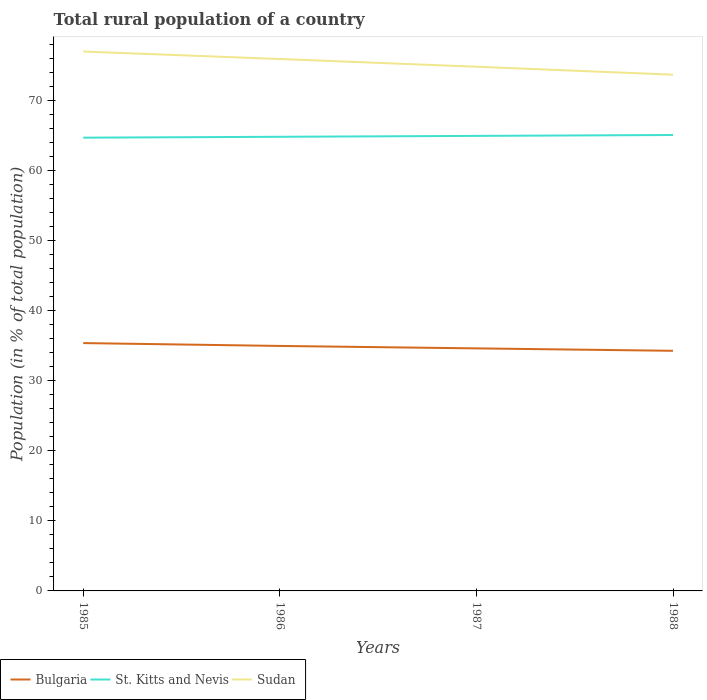How many different coloured lines are there?
Your response must be concise. 3. Is the number of lines equal to the number of legend labels?
Give a very brief answer. Yes. Across all years, what is the maximum rural population in Sudan?
Keep it short and to the point. 73.76. What is the total rural population in Bulgaria in the graph?
Provide a short and direct response. 1.1. What is the difference between the highest and the second highest rural population in Sudan?
Provide a short and direct response. 3.31. What is the difference between the highest and the lowest rural population in St. Kitts and Nevis?
Offer a terse response. 2. How many lines are there?
Your response must be concise. 3. How many years are there in the graph?
Offer a very short reply. 4. What is the difference between two consecutive major ticks on the Y-axis?
Keep it short and to the point. 10. Are the values on the major ticks of Y-axis written in scientific E-notation?
Offer a terse response. No. Where does the legend appear in the graph?
Give a very brief answer. Bottom left. How many legend labels are there?
Provide a short and direct response. 3. How are the legend labels stacked?
Make the answer very short. Horizontal. What is the title of the graph?
Your response must be concise. Total rural population of a country. What is the label or title of the X-axis?
Keep it short and to the point. Years. What is the label or title of the Y-axis?
Keep it short and to the point. Population (in % of total population). What is the Population (in % of total population) in Bulgaria in 1985?
Give a very brief answer. 35.41. What is the Population (in % of total population) in St. Kitts and Nevis in 1985?
Make the answer very short. 64.76. What is the Population (in % of total population) in Sudan in 1985?
Offer a very short reply. 77.06. What is the Population (in % of total population) of Bulgaria in 1986?
Your answer should be very brief. 35. What is the Population (in % of total population) of St. Kitts and Nevis in 1986?
Provide a short and direct response. 64.88. What is the Population (in % of total population) of Sudan in 1986?
Your response must be concise. 76. What is the Population (in % of total population) of Bulgaria in 1987?
Keep it short and to the point. 34.65. What is the Population (in % of total population) of St. Kitts and Nevis in 1987?
Provide a short and direct response. 65.01. What is the Population (in % of total population) of Sudan in 1987?
Make the answer very short. 74.89. What is the Population (in % of total population) in Bulgaria in 1988?
Provide a succinct answer. 34.31. What is the Population (in % of total population) of St. Kitts and Nevis in 1988?
Offer a very short reply. 65.14. What is the Population (in % of total population) in Sudan in 1988?
Ensure brevity in your answer.  73.76. Across all years, what is the maximum Population (in % of total population) in Bulgaria?
Provide a short and direct response. 35.41. Across all years, what is the maximum Population (in % of total population) of St. Kitts and Nevis?
Provide a short and direct response. 65.14. Across all years, what is the maximum Population (in % of total population) in Sudan?
Offer a very short reply. 77.06. Across all years, what is the minimum Population (in % of total population) in Bulgaria?
Provide a short and direct response. 34.31. Across all years, what is the minimum Population (in % of total population) in St. Kitts and Nevis?
Your response must be concise. 64.76. Across all years, what is the minimum Population (in % of total population) in Sudan?
Make the answer very short. 73.76. What is the total Population (in % of total population) of Bulgaria in the graph?
Your answer should be very brief. 139.37. What is the total Population (in % of total population) in St. Kitts and Nevis in the graph?
Your answer should be very brief. 259.79. What is the total Population (in % of total population) of Sudan in the graph?
Give a very brief answer. 301.71. What is the difference between the Population (in % of total population) of Bulgaria in 1985 and that in 1986?
Make the answer very short. 0.41. What is the difference between the Population (in % of total population) of St. Kitts and Nevis in 1985 and that in 1986?
Ensure brevity in your answer.  -0.13. What is the difference between the Population (in % of total population) in Sudan in 1985 and that in 1986?
Your answer should be compact. 1.07. What is the difference between the Population (in % of total population) of Bulgaria in 1985 and that in 1987?
Offer a terse response. 0.76. What is the difference between the Population (in % of total population) of St. Kitts and Nevis in 1985 and that in 1987?
Give a very brief answer. -0.25. What is the difference between the Population (in % of total population) in Sudan in 1985 and that in 1987?
Offer a terse response. 2.17. What is the difference between the Population (in % of total population) in Bulgaria in 1985 and that in 1988?
Ensure brevity in your answer.  1.1. What is the difference between the Population (in % of total population) in St. Kitts and Nevis in 1985 and that in 1988?
Make the answer very short. -0.38. What is the difference between the Population (in % of total population) of Sudan in 1985 and that in 1988?
Your response must be concise. 3.31. What is the difference between the Population (in % of total population) of Bulgaria in 1986 and that in 1987?
Give a very brief answer. 0.35. What is the difference between the Population (in % of total population) of St. Kitts and Nevis in 1986 and that in 1987?
Keep it short and to the point. -0.13. What is the difference between the Population (in % of total population) of Sudan in 1986 and that in 1987?
Give a very brief answer. 1.1. What is the difference between the Population (in % of total population) of Bulgaria in 1986 and that in 1988?
Keep it short and to the point. 0.69. What is the difference between the Population (in % of total population) in St. Kitts and Nevis in 1986 and that in 1988?
Give a very brief answer. -0.25. What is the difference between the Population (in % of total population) of Sudan in 1986 and that in 1988?
Offer a terse response. 2.24. What is the difference between the Population (in % of total population) in Bulgaria in 1987 and that in 1988?
Your answer should be compact. 0.35. What is the difference between the Population (in % of total population) of St. Kitts and Nevis in 1987 and that in 1988?
Provide a short and direct response. -0.13. What is the difference between the Population (in % of total population) of Sudan in 1987 and that in 1988?
Provide a short and direct response. 1.14. What is the difference between the Population (in % of total population) of Bulgaria in 1985 and the Population (in % of total population) of St. Kitts and Nevis in 1986?
Make the answer very short. -29.47. What is the difference between the Population (in % of total population) of Bulgaria in 1985 and the Population (in % of total population) of Sudan in 1986?
Provide a succinct answer. -40.59. What is the difference between the Population (in % of total population) of St. Kitts and Nevis in 1985 and the Population (in % of total population) of Sudan in 1986?
Your response must be concise. -11.24. What is the difference between the Population (in % of total population) in Bulgaria in 1985 and the Population (in % of total population) in St. Kitts and Nevis in 1987?
Your answer should be compact. -29.6. What is the difference between the Population (in % of total population) in Bulgaria in 1985 and the Population (in % of total population) in Sudan in 1987?
Offer a terse response. -39.48. What is the difference between the Population (in % of total population) of St. Kitts and Nevis in 1985 and the Population (in % of total population) of Sudan in 1987?
Give a very brief answer. -10.14. What is the difference between the Population (in % of total population) in Bulgaria in 1985 and the Population (in % of total population) in St. Kitts and Nevis in 1988?
Give a very brief answer. -29.73. What is the difference between the Population (in % of total population) of Bulgaria in 1985 and the Population (in % of total population) of Sudan in 1988?
Your response must be concise. -38.35. What is the difference between the Population (in % of total population) in St. Kitts and Nevis in 1985 and the Population (in % of total population) in Sudan in 1988?
Your answer should be compact. -9. What is the difference between the Population (in % of total population) in Bulgaria in 1986 and the Population (in % of total population) in St. Kitts and Nevis in 1987?
Offer a terse response. -30.01. What is the difference between the Population (in % of total population) of Bulgaria in 1986 and the Population (in % of total population) of Sudan in 1987?
Ensure brevity in your answer.  -39.89. What is the difference between the Population (in % of total population) in St. Kitts and Nevis in 1986 and the Population (in % of total population) in Sudan in 1987?
Offer a terse response. -10.01. What is the difference between the Population (in % of total population) in Bulgaria in 1986 and the Population (in % of total population) in St. Kitts and Nevis in 1988?
Your answer should be very brief. -30.14. What is the difference between the Population (in % of total population) in Bulgaria in 1986 and the Population (in % of total population) in Sudan in 1988?
Your answer should be compact. -38.76. What is the difference between the Population (in % of total population) in St. Kitts and Nevis in 1986 and the Population (in % of total population) in Sudan in 1988?
Make the answer very short. -8.87. What is the difference between the Population (in % of total population) of Bulgaria in 1987 and the Population (in % of total population) of St. Kitts and Nevis in 1988?
Ensure brevity in your answer.  -30.48. What is the difference between the Population (in % of total population) of Bulgaria in 1987 and the Population (in % of total population) of Sudan in 1988?
Provide a short and direct response. -39.1. What is the difference between the Population (in % of total population) in St. Kitts and Nevis in 1987 and the Population (in % of total population) in Sudan in 1988?
Provide a short and direct response. -8.74. What is the average Population (in % of total population) of Bulgaria per year?
Give a very brief answer. 34.84. What is the average Population (in % of total population) in St. Kitts and Nevis per year?
Your response must be concise. 64.95. What is the average Population (in % of total population) of Sudan per year?
Your answer should be compact. 75.43. In the year 1985, what is the difference between the Population (in % of total population) of Bulgaria and Population (in % of total population) of St. Kitts and Nevis?
Make the answer very short. -29.35. In the year 1985, what is the difference between the Population (in % of total population) of Bulgaria and Population (in % of total population) of Sudan?
Ensure brevity in your answer.  -41.65. In the year 1985, what is the difference between the Population (in % of total population) in St. Kitts and Nevis and Population (in % of total population) in Sudan?
Offer a very short reply. -12.31. In the year 1986, what is the difference between the Population (in % of total population) in Bulgaria and Population (in % of total population) in St. Kitts and Nevis?
Your answer should be compact. -29.88. In the year 1986, what is the difference between the Population (in % of total population) of Bulgaria and Population (in % of total population) of Sudan?
Give a very brief answer. -40.99. In the year 1986, what is the difference between the Population (in % of total population) of St. Kitts and Nevis and Population (in % of total population) of Sudan?
Your response must be concise. -11.11. In the year 1987, what is the difference between the Population (in % of total population) in Bulgaria and Population (in % of total population) in St. Kitts and Nevis?
Your response must be concise. -30.36. In the year 1987, what is the difference between the Population (in % of total population) of Bulgaria and Population (in % of total population) of Sudan?
Make the answer very short. -40.24. In the year 1987, what is the difference between the Population (in % of total population) in St. Kitts and Nevis and Population (in % of total population) in Sudan?
Provide a short and direct response. -9.88. In the year 1988, what is the difference between the Population (in % of total population) in Bulgaria and Population (in % of total population) in St. Kitts and Nevis?
Give a very brief answer. -30.83. In the year 1988, what is the difference between the Population (in % of total population) of Bulgaria and Population (in % of total population) of Sudan?
Give a very brief answer. -39.45. In the year 1988, what is the difference between the Population (in % of total population) of St. Kitts and Nevis and Population (in % of total population) of Sudan?
Ensure brevity in your answer.  -8.62. What is the ratio of the Population (in % of total population) of Bulgaria in 1985 to that in 1986?
Ensure brevity in your answer.  1.01. What is the ratio of the Population (in % of total population) in Sudan in 1985 to that in 1986?
Your answer should be very brief. 1.01. What is the ratio of the Population (in % of total population) in Bulgaria in 1985 to that in 1987?
Provide a succinct answer. 1.02. What is the ratio of the Population (in % of total population) of Bulgaria in 1985 to that in 1988?
Provide a short and direct response. 1.03. What is the ratio of the Population (in % of total population) of St. Kitts and Nevis in 1985 to that in 1988?
Give a very brief answer. 0.99. What is the ratio of the Population (in % of total population) in Sudan in 1985 to that in 1988?
Make the answer very short. 1.04. What is the ratio of the Population (in % of total population) in St. Kitts and Nevis in 1986 to that in 1987?
Provide a succinct answer. 1. What is the ratio of the Population (in % of total population) of Sudan in 1986 to that in 1987?
Provide a succinct answer. 1.01. What is the ratio of the Population (in % of total population) in Bulgaria in 1986 to that in 1988?
Offer a terse response. 1.02. What is the ratio of the Population (in % of total population) of St. Kitts and Nevis in 1986 to that in 1988?
Offer a very short reply. 1. What is the ratio of the Population (in % of total population) of Sudan in 1986 to that in 1988?
Make the answer very short. 1.03. What is the ratio of the Population (in % of total population) in Bulgaria in 1987 to that in 1988?
Offer a terse response. 1.01. What is the ratio of the Population (in % of total population) of Sudan in 1987 to that in 1988?
Give a very brief answer. 1.02. What is the difference between the highest and the second highest Population (in % of total population) of Bulgaria?
Ensure brevity in your answer.  0.41. What is the difference between the highest and the second highest Population (in % of total population) in St. Kitts and Nevis?
Make the answer very short. 0.13. What is the difference between the highest and the second highest Population (in % of total population) of Sudan?
Give a very brief answer. 1.07. What is the difference between the highest and the lowest Population (in % of total population) in Bulgaria?
Offer a very short reply. 1.1. What is the difference between the highest and the lowest Population (in % of total population) of St. Kitts and Nevis?
Provide a short and direct response. 0.38. What is the difference between the highest and the lowest Population (in % of total population) in Sudan?
Your answer should be very brief. 3.31. 